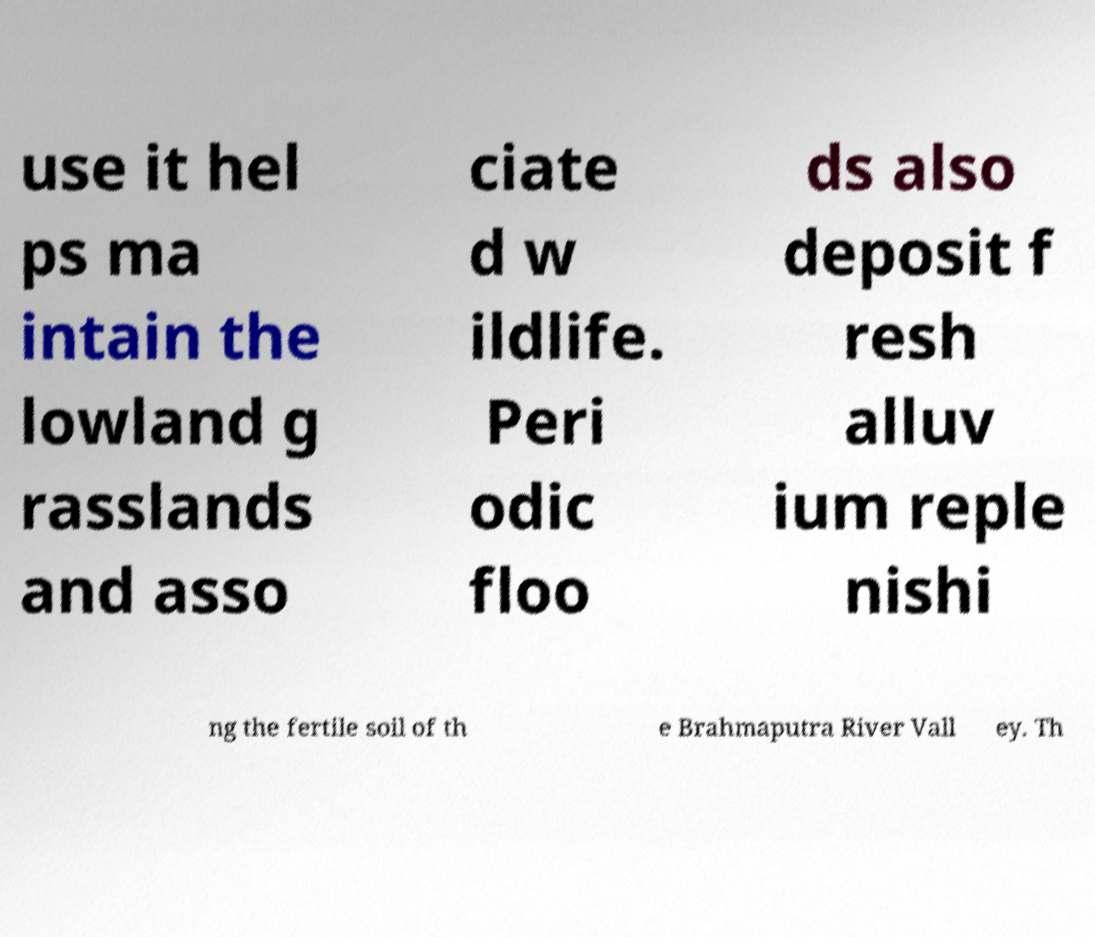Could you assist in decoding the text presented in this image and type it out clearly? use it hel ps ma intain the lowland g rasslands and asso ciate d w ildlife. Peri odic floo ds also deposit f resh alluv ium reple nishi ng the fertile soil of th e Brahmaputra River Vall ey. Th 